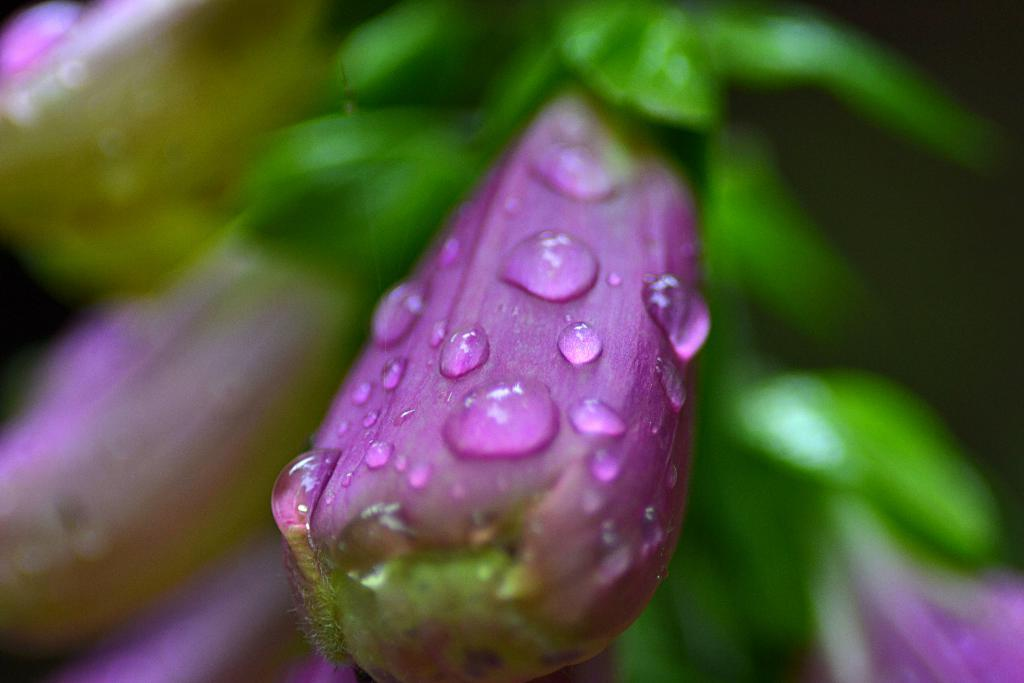What type of plant is featured in the image? There is a plant with violet color flowers in the image. Can you describe the appearance of the flowers? The flowers have water drops on them. What can be observed about the background of the image? The background of the image is blurred. What type of cannon is present in the image? There is no cannon present in the image; it features a plant with violet flowers and water drops on the flowers. What type of skirt is visible on the plant in the image? There is no skirt present in the image; it features a plant with violet flowers and water drops on the flowers. 